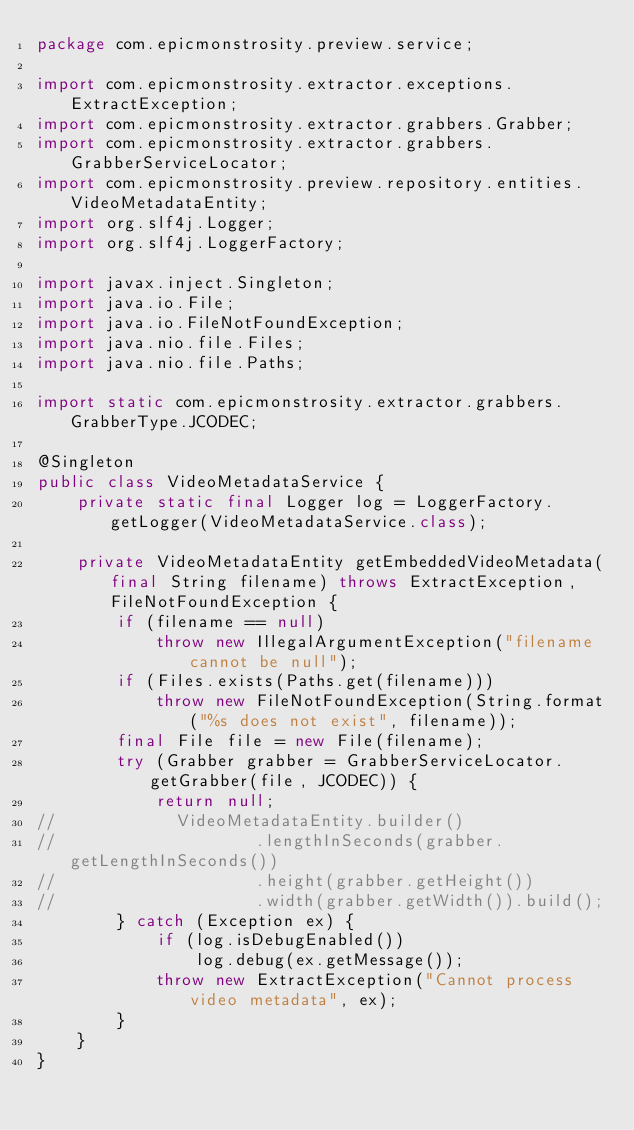<code> <loc_0><loc_0><loc_500><loc_500><_Java_>package com.epicmonstrosity.preview.service;

import com.epicmonstrosity.extractor.exceptions.ExtractException;
import com.epicmonstrosity.extractor.grabbers.Grabber;
import com.epicmonstrosity.extractor.grabbers.GrabberServiceLocator;
import com.epicmonstrosity.preview.repository.entities.VideoMetadataEntity;
import org.slf4j.Logger;
import org.slf4j.LoggerFactory;

import javax.inject.Singleton;
import java.io.File;
import java.io.FileNotFoundException;
import java.nio.file.Files;
import java.nio.file.Paths;

import static com.epicmonstrosity.extractor.grabbers.GrabberType.JCODEC;

@Singleton
public class VideoMetadataService {
    private static final Logger log = LoggerFactory.getLogger(VideoMetadataService.class);

    private VideoMetadataEntity getEmbeddedVideoMetadata(final String filename) throws ExtractException, FileNotFoundException {
        if (filename == null)
            throw new IllegalArgumentException("filename cannot be null");
        if (Files.exists(Paths.get(filename)))
            throw new FileNotFoundException(String.format("%s does not exist", filename));
        final File file = new File(filename);
        try (Grabber grabber = GrabberServiceLocator.getGrabber(file, JCODEC)) {
            return null;
//            VideoMetadataEntity.builder()
//                    .lengthInSeconds(grabber.getLengthInSeconds())
//                    .height(grabber.getHeight())
//                    .width(grabber.getWidth()).build();
        } catch (Exception ex) {
            if (log.isDebugEnabled())
                log.debug(ex.getMessage());
            throw new ExtractException("Cannot process video metadata", ex);
        }
    }
}
</code> 